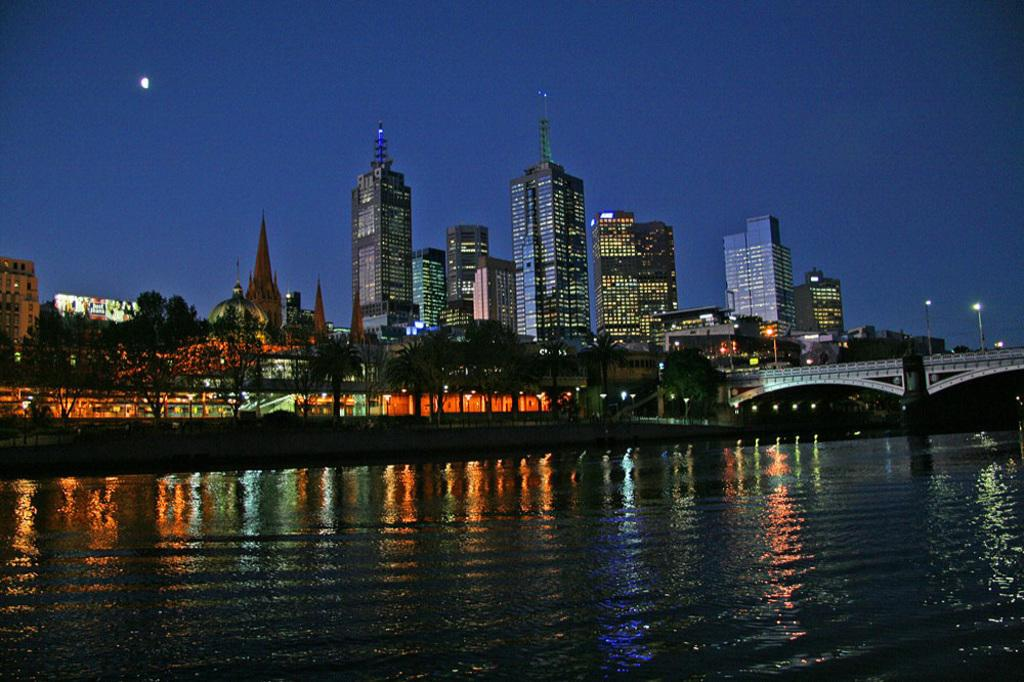What type of structures can be seen in the image? There are buildings in the image. What natural elements are present in the image? There are trees in the image. What architectural feature is visible in the image? There is a bridge in the image. What can be seen at the bottom of the image? There is water visible at the bottom of the image. What additional features can be observed in the background of the image? There are lights and the sky visible in the background of the image. Where is the prison located in the image? There is no prison present in the image. Is there a hill visible in the image? There is no hill visible in the image. 